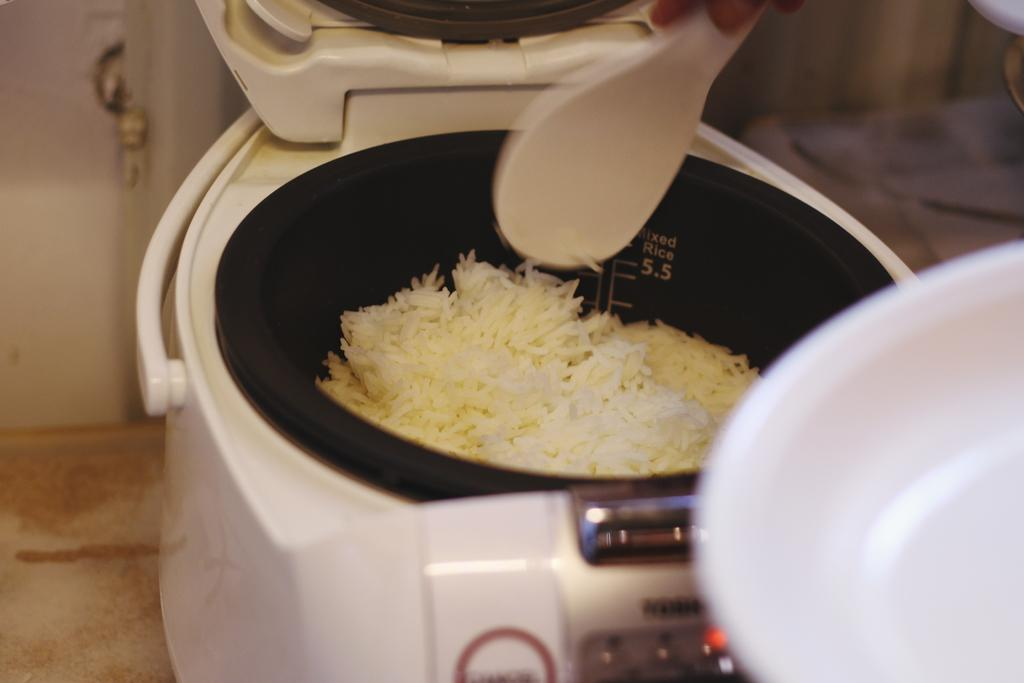Provide a one-sentence caption for the provided image. An open rice cooker that indicates it's for mixed rice on the inside is partially full of rice. 